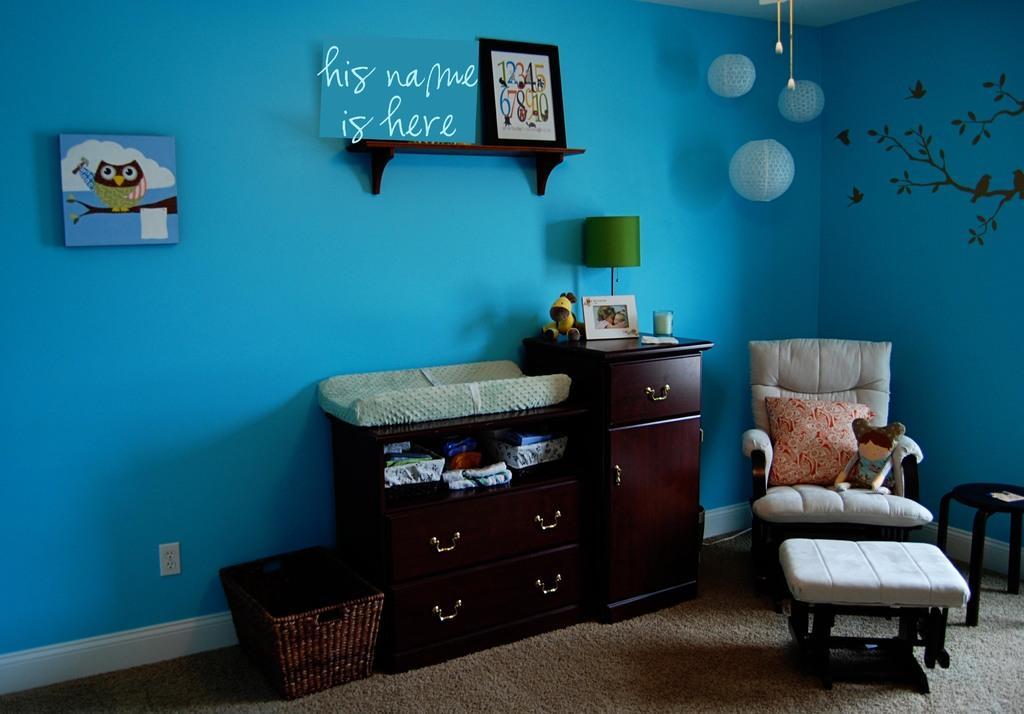How would you summarize this image in a sentence or two? It is a bed room painted in sky blue with a furniture,lamp and few frames on the wall. 